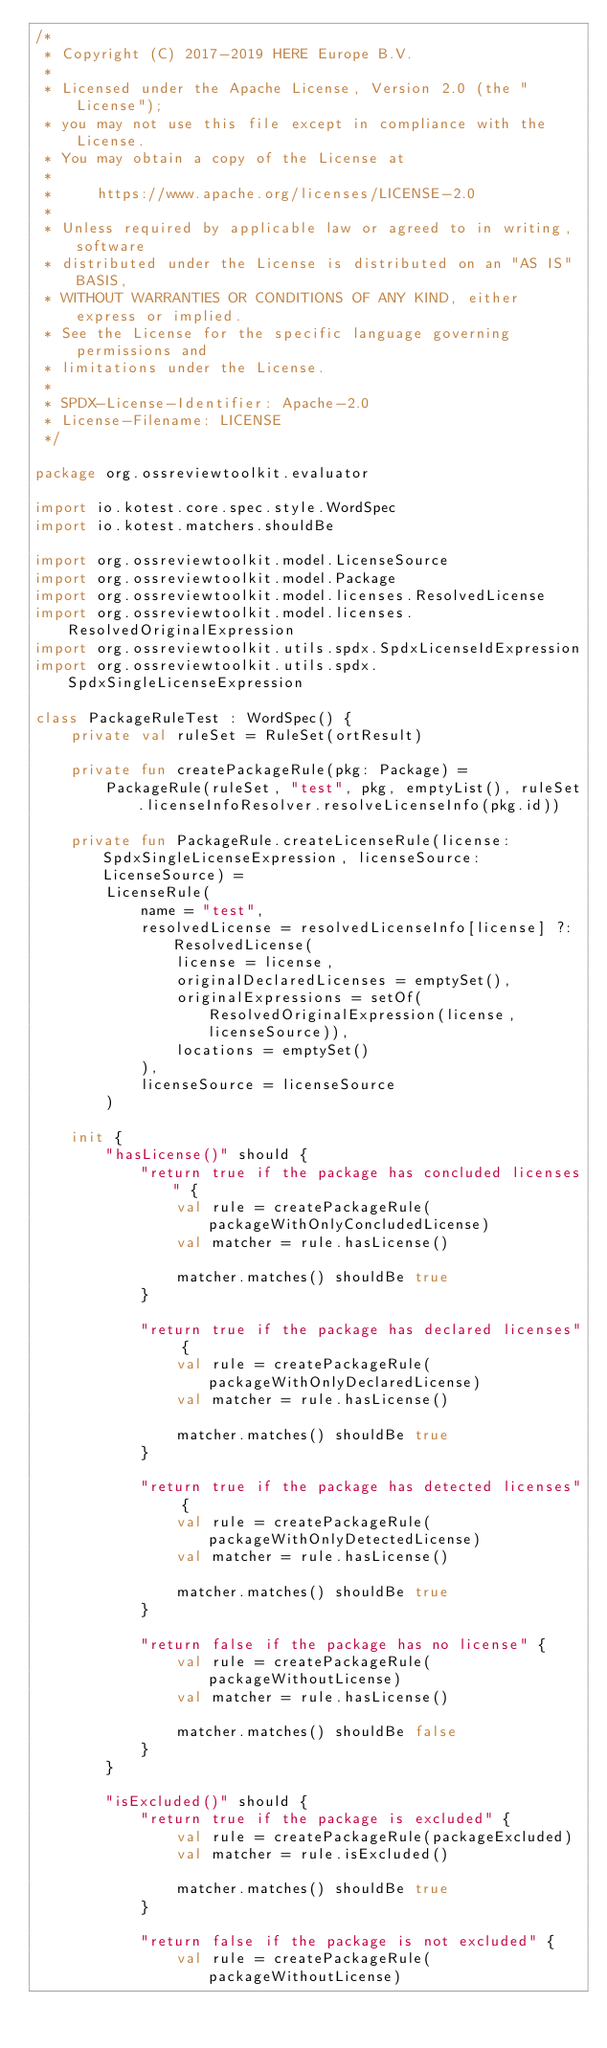<code> <loc_0><loc_0><loc_500><loc_500><_Kotlin_>/*
 * Copyright (C) 2017-2019 HERE Europe B.V.
 *
 * Licensed under the Apache License, Version 2.0 (the "License");
 * you may not use this file except in compliance with the License.
 * You may obtain a copy of the License at
 *
 *     https://www.apache.org/licenses/LICENSE-2.0
 *
 * Unless required by applicable law or agreed to in writing, software
 * distributed under the License is distributed on an "AS IS" BASIS,
 * WITHOUT WARRANTIES OR CONDITIONS OF ANY KIND, either express or implied.
 * See the License for the specific language governing permissions and
 * limitations under the License.
 *
 * SPDX-License-Identifier: Apache-2.0
 * License-Filename: LICENSE
 */

package org.ossreviewtoolkit.evaluator

import io.kotest.core.spec.style.WordSpec
import io.kotest.matchers.shouldBe

import org.ossreviewtoolkit.model.LicenseSource
import org.ossreviewtoolkit.model.Package
import org.ossreviewtoolkit.model.licenses.ResolvedLicense
import org.ossreviewtoolkit.model.licenses.ResolvedOriginalExpression
import org.ossreviewtoolkit.utils.spdx.SpdxLicenseIdExpression
import org.ossreviewtoolkit.utils.spdx.SpdxSingleLicenseExpression

class PackageRuleTest : WordSpec() {
    private val ruleSet = RuleSet(ortResult)

    private fun createPackageRule(pkg: Package) =
        PackageRule(ruleSet, "test", pkg, emptyList(), ruleSet.licenseInfoResolver.resolveLicenseInfo(pkg.id))

    private fun PackageRule.createLicenseRule(license: SpdxSingleLicenseExpression, licenseSource: LicenseSource) =
        LicenseRule(
            name = "test",
            resolvedLicense = resolvedLicenseInfo[license] ?: ResolvedLicense(
                license = license,
                originalDeclaredLicenses = emptySet(),
                originalExpressions = setOf(ResolvedOriginalExpression(license, licenseSource)),
                locations = emptySet()
            ),
            licenseSource = licenseSource
        )

    init {
        "hasLicense()" should {
            "return true if the package has concluded licenses" {
                val rule = createPackageRule(packageWithOnlyConcludedLicense)
                val matcher = rule.hasLicense()

                matcher.matches() shouldBe true
            }

            "return true if the package has declared licenses" {
                val rule = createPackageRule(packageWithOnlyDeclaredLicense)
                val matcher = rule.hasLicense()

                matcher.matches() shouldBe true
            }

            "return true if the package has detected licenses" {
                val rule = createPackageRule(packageWithOnlyDetectedLicense)
                val matcher = rule.hasLicense()

                matcher.matches() shouldBe true
            }

            "return false if the package has no license" {
                val rule = createPackageRule(packageWithoutLicense)
                val matcher = rule.hasLicense()

                matcher.matches() shouldBe false
            }
        }

        "isExcluded()" should {
            "return true if the package is excluded" {
                val rule = createPackageRule(packageExcluded)
                val matcher = rule.isExcluded()

                matcher.matches() shouldBe true
            }

            "return false if the package is not excluded" {
                val rule = createPackageRule(packageWithoutLicense)</code> 